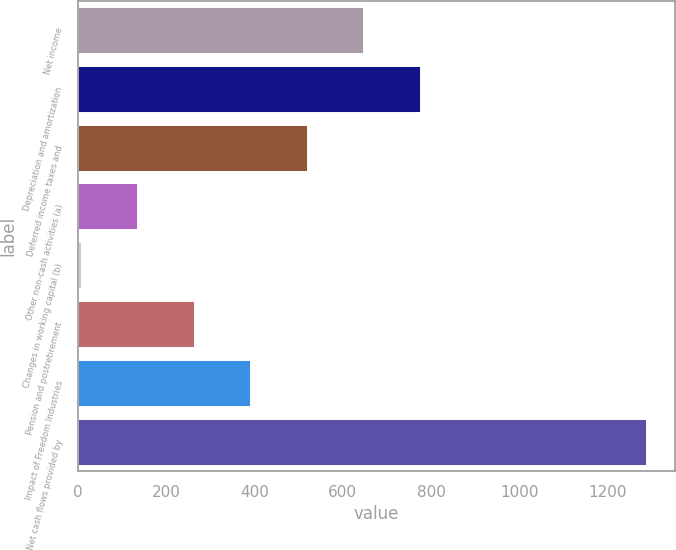Convert chart. <chart><loc_0><loc_0><loc_500><loc_500><bar_chart><fcel>Net income<fcel>Depreciation and amortization<fcel>Deferred income taxes and<fcel>Other non-cash activities (a)<fcel>Changes in working capital (b)<fcel>Pension and postretirement<fcel>Impact of Freedom Industries<fcel>Net cash flows provided by<nl><fcel>649<fcel>777<fcel>521<fcel>137<fcel>9<fcel>265<fcel>393<fcel>1289<nl></chart> 